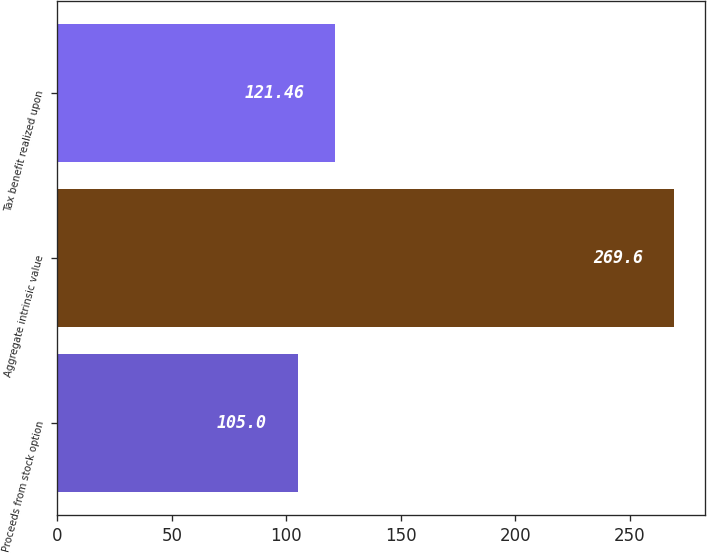Convert chart to OTSL. <chart><loc_0><loc_0><loc_500><loc_500><bar_chart><fcel>Proceeds from stock option<fcel>Aggregate intrinsic value<fcel>Tax benefit realized upon<nl><fcel>105<fcel>269.6<fcel>121.46<nl></chart> 